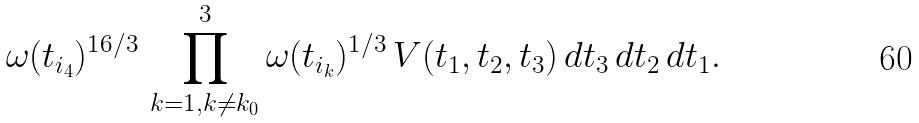<formula> <loc_0><loc_0><loc_500><loc_500>\omega ( t _ { i _ { 4 } } ) ^ { 1 6 / 3 } \, \prod _ { k = 1 , k \not = k _ { 0 } } ^ { 3 } \omega ( t _ { i _ { k } } ) ^ { 1 / 3 } \, V ( t _ { 1 } , t _ { 2 } , t _ { 3 } ) \, d t _ { 3 } \, d t _ { 2 } \, d t _ { 1 } .</formula> 